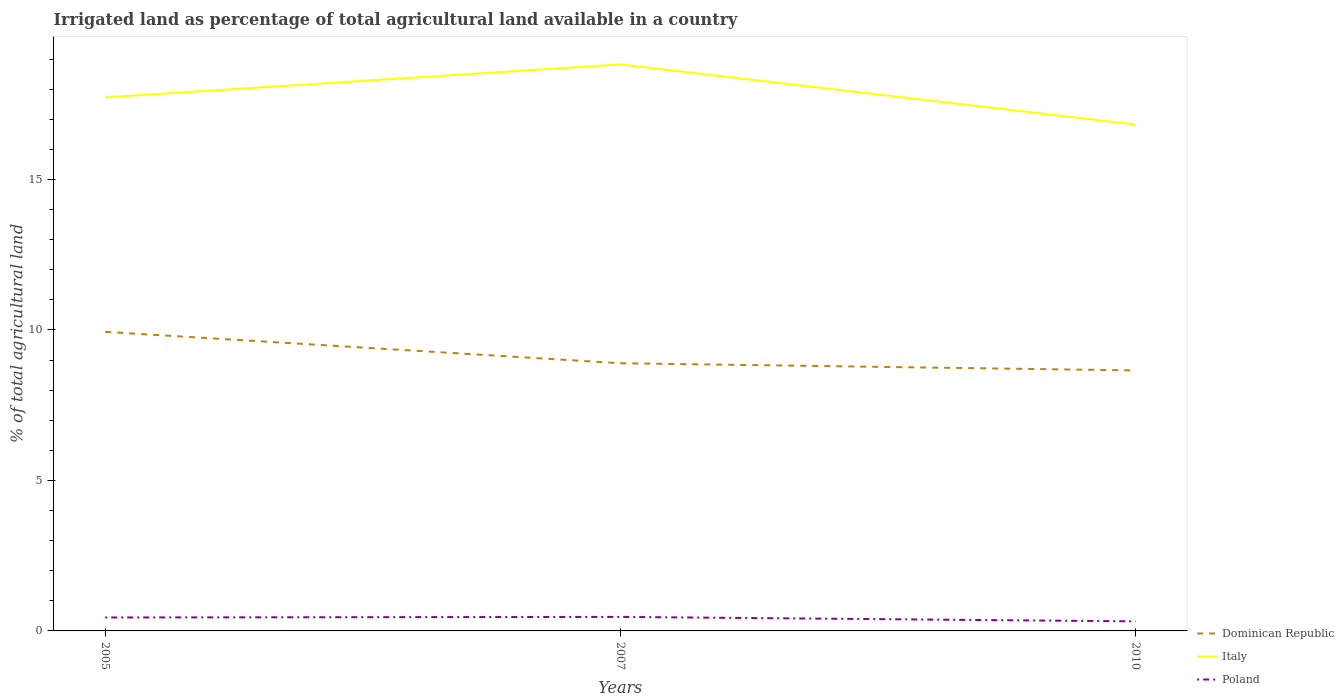How many different coloured lines are there?
Ensure brevity in your answer.  3. Across all years, what is the maximum percentage of irrigated land in Poland?
Your answer should be very brief. 0.32. What is the total percentage of irrigated land in Italy in the graph?
Your response must be concise. 2. What is the difference between the highest and the second highest percentage of irrigated land in Poland?
Ensure brevity in your answer.  0.15. How many lines are there?
Keep it short and to the point. 3. How many years are there in the graph?
Your answer should be compact. 3. What is the difference between two consecutive major ticks on the Y-axis?
Offer a very short reply. 5. How many legend labels are there?
Your answer should be compact. 3. How are the legend labels stacked?
Offer a terse response. Vertical. What is the title of the graph?
Provide a short and direct response. Irrigated land as percentage of total agricultural land available in a country. Does "Mauritania" appear as one of the legend labels in the graph?
Make the answer very short. No. What is the label or title of the Y-axis?
Make the answer very short. % of total agricultural land. What is the % of total agricultural land of Dominican Republic in 2005?
Provide a short and direct response. 9.94. What is the % of total agricultural land in Italy in 2005?
Your response must be concise. 17.73. What is the % of total agricultural land of Poland in 2005?
Give a very brief answer. 0.45. What is the % of total agricultural land in Dominican Republic in 2007?
Provide a succinct answer. 8.9. What is the % of total agricultural land of Italy in 2007?
Provide a succinct answer. 18.83. What is the % of total agricultural land in Poland in 2007?
Provide a succinct answer. 0.47. What is the % of total agricultural land in Dominican Republic in 2010?
Ensure brevity in your answer.  8.66. What is the % of total agricultural land of Italy in 2010?
Provide a succinct answer. 16.83. What is the % of total agricultural land of Poland in 2010?
Make the answer very short. 0.32. Across all years, what is the maximum % of total agricultural land in Dominican Republic?
Give a very brief answer. 9.94. Across all years, what is the maximum % of total agricultural land of Italy?
Keep it short and to the point. 18.83. Across all years, what is the maximum % of total agricultural land in Poland?
Your response must be concise. 0.47. Across all years, what is the minimum % of total agricultural land in Dominican Republic?
Offer a very short reply. 8.66. Across all years, what is the minimum % of total agricultural land of Italy?
Offer a terse response. 16.83. Across all years, what is the minimum % of total agricultural land in Poland?
Offer a very short reply. 0.32. What is the total % of total agricultural land of Dominican Republic in the graph?
Give a very brief answer. 27.49. What is the total % of total agricultural land of Italy in the graph?
Keep it short and to the point. 53.38. What is the total % of total agricultural land in Poland in the graph?
Offer a very short reply. 1.23. What is the difference between the % of total agricultural land of Dominican Republic in 2005 and that in 2007?
Provide a succinct answer. 1.04. What is the difference between the % of total agricultural land of Italy in 2005 and that in 2007?
Your response must be concise. -1.09. What is the difference between the % of total agricultural land in Poland in 2005 and that in 2007?
Keep it short and to the point. -0.02. What is the difference between the % of total agricultural land of Dominican Republic in 2005 and that in 2010?
Make the answer very short. 1.28. What is the difference between the % of total agricultural land in Italy in 2005 and that in 2010?
Make the answer very short. 0.9. What is the difference between the % of total agricultural land of Poland in 2005 and that in 2010?
Make the answer very short. 0.13. What is the difference between the % of total agricultural land of Dominican Republic in 2007 and that in 2010?
Your answer should be compact. 0.24. What is the difference between the % of total agricultural land in Italy in 2007 and that in 2010?
Your answer should be very brief. 2. What is the difference between the % of total agricultural land of Poland in 2007 and that in 2010?
Give a very brief answer. 0.15. What is the difference between the % of total agricultural land of Dominican Republic in 2005 and the % of total agricultural land of Italy in 2007?
Your answer should be very brief. -8.89. What is the difference between the % of total agricultural land of Dominican Republic in 2005 and the % of total agricultural land of Poland in 2007?
Your response must be concise. 9.47. What is the difference between the % of total agricultural land in Italy in 2005 and the % of total agricultural land in Poland in 2007?
Offer a terse response. 17.27. What is the difference between the % of total agricultural land in Dominican Republic in 2005 and the % of total agricultural land in Italy in 2010?
Offer a very short reply. -6.89. What is the difference between the % of total agricultural land of Dominican Republic in 2005 and the % of total agricultural land of Poland in 2010?
Your response must be concise. 9.62. What is the difference between the % of total agricultural land of Italy in 2005 and the % of total agricultural land of Poland in 2010?
Provide a short and direct response. 17.41. What is the difference between the % of total agricultural land in Dominican Republic in 2007 and the % of total agricultural land in Italy in 2010?
Keep it short and to the point. -7.93. What is the difference between the % of total agricultural land of Dominican Republic in 2007 and the % of total agricultural land of Poland in 2010?
Ensure brevity in your answer.  8.58. What is the difference between the % of total agricultural land in Italy in 2007 and the % of total agricultural land in Poland in 2010?
Offer a terse response. 18.51. What is the average % of total agricultural land in Dominican Republic per year?
Provide a succinct answer. 9.16. What is the average % of total agricultural land in Italy per year?
Offer a very short reply. 17.79. What is the average % of total agricultural land of Poland per year?
Ensure brevity in your answer.  0.41. In the year 2005, what is the difference between the % of total agricultural land of Dominican Republic and % of total agricultural land of Italy?
Offer a terse response. -7.79. In the year 2005, what is the difference between the % of total agricultural land of Dominican Republic and % of total agricultural land of Poland?
Provide a succinct answer. 9.49. In the year 2005, what is the difference between the % of total agricultural land in Italy and % of total agricultural land in Poland?
Your answer should be compact. 17.29. In the year 2007, what is the difference between the % of total agricultural land of Dominican Republic and % of total agricultural land of Italy?
Provide a short and direct response. -9.93. In the year 2007, what is the difference between the % of total agricultural land of Dominican Republic and % of total agricultural land of Poland?
Provide a short and direct response. 8.43. In the year 2007, what is the difference between the % of total agricultural land of Italy and % of total agricultural land of Poland?
Make the answer very short. 18.36. In the year 2010, what is the difference between the % of total agricultural land in Dominican Republic and % of total agricultural land in Italy?
Offer a very short reply. -8.17. In the year 2010, what is the difference between the % of total agricultural land in Dominican Republic and % of total agricultural land in Poland?
Make the answer very short. 8.34. In the year 2010, what is the difference between the % of total agricultural land in Italy and % of total agricultural land in Poland?
Provide a short and direct response. 16.51. What is the ratio of the % of total agricultural land in Dominican Republic in 2005 to that in 2007?
Your answer should be compact. 1.12. What is the ratio of the % of total agricultural land of Italy in 2005 to that in 2007?
Make the answer very short. 0.94. What is the ratio of the % of total agricultural land in Dominican Republic in 2005 to that in 2010?
Ensure brevity in your answer.  1.15. What is the ratio of the % of total agricultural land of Italy in 2005 to that in 2010?
Offer a terse response. 1.05. What is the ratio of the % of total agricultural land of Poland in 2005 to that in 2010?
Make the answer very short. 1.4. What is the ratio of the % of total agricultural land of Dominican Republic in 2007 to that in 2010?
Offer a very short reply. 1.03. What is the ratio of the % of total agricultural land of Italy in 2007 to that in 2010?
Keep it short and to the point. 1.12. What is the ratio of the % of total agricultural land in Poland in 2007 to that in 2010?
Provide a short and direct response. 1.46. What is the difference between the highest and the second highest % of total agricultural land of Dominican Republic?
Ensure brevity in your answer.  1.04. What is the difference between the highest and the second highest % of total agricultural land in Italy?
Offer a terse response. 1.09. What is the difference between the highest and the second highest % of total agricultural land of Poland?
Provide a succinct answer. 0.02. What is the difference between the highest and the lowest % of total agricultural land of Dominican Republic?
Keep it short and to the point. 1.28. What is the difference between the highest and the lowest % of total agricultural land of Italy?
Keep it short and to the point. 2. What is the difference between the highest and the lowest % of total agricultural land in Poland?
Offer a very short reply. 0.15. 